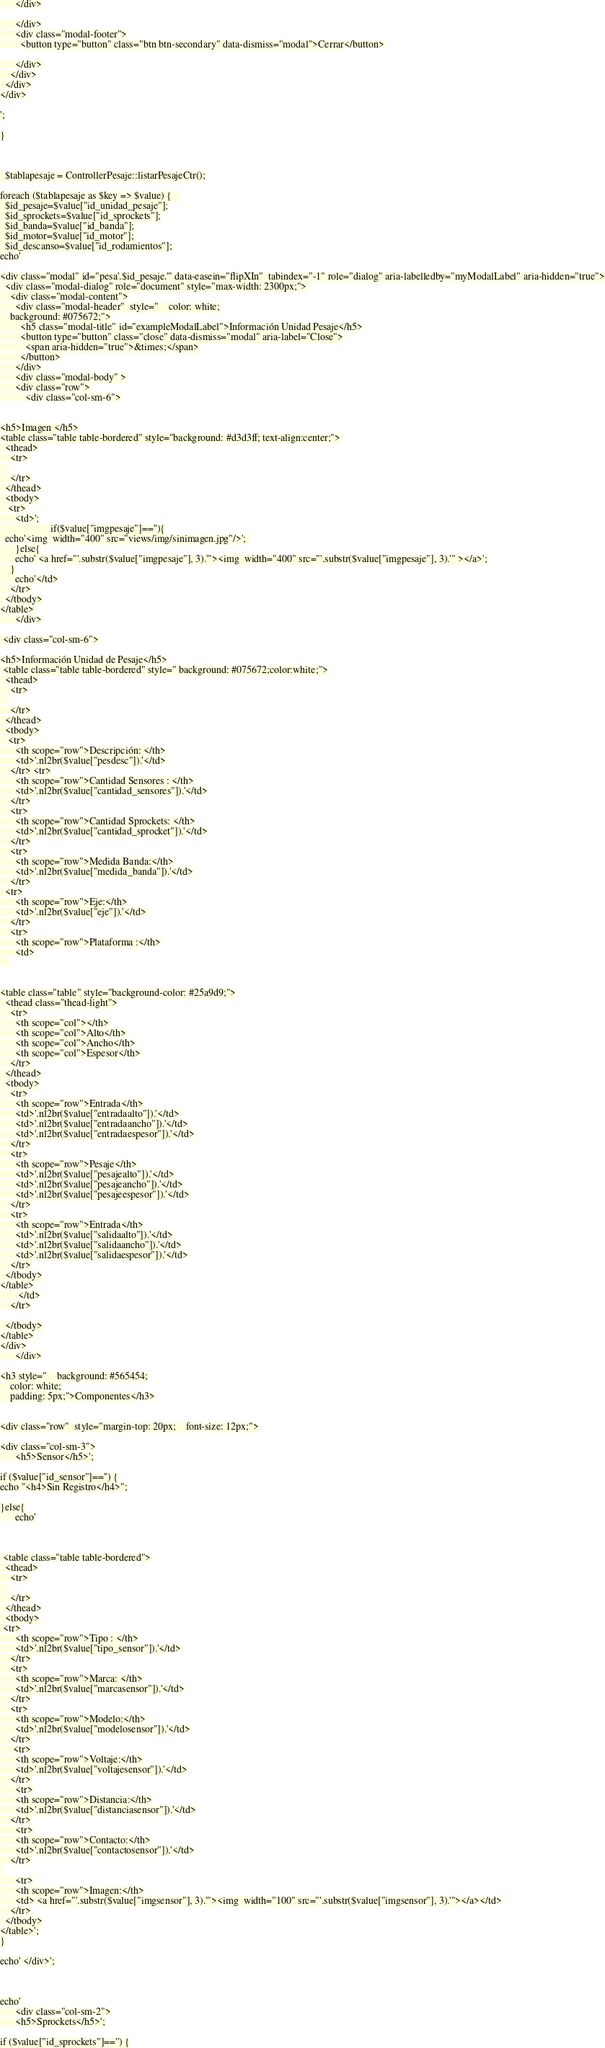Convert code to text. <code><loc_0><loc_0><loc_500><loc_500><_PHP_>
      </div>

      </div>
      <div class="modal-footer">
        <button type="button" class="btn btn-secondary" data-dismiss="modal">Cerrar</button>

      </div>
    </div>
  </div>
</div>

';

}



  $tablapesaje = ControllerPesaje::listarPesajeCtr();

foreach ($tablapesaje as $key => $value) {   
  $id_pesaje=$value["id_unidad_pesaje"];
  $id_sprockets=$value["id_sprockets"];
  $id_banda=$value["id_banda"];
  $id_motor=$value["id_motor"];
  $id_descanso=$value["id_rodamientos"];
echo'

<div class="modal" id="pesa'.$id_pesaje.'" data-easein="flipXIn"  tabindex="-1" role="dialog" aria-labelledby="myModalLabel" aria-hidden="true">
  <div class="modal-dialog" role="document" style="max-width: 2300px;">
    <div class="modal-content">
      <div class="modal-header"  style="    color: white;
    background: #075672;">
        <h5 class="modal-title" id="exampleModalLabel">Información Unidad Pesaje</h5>
        <button type="button" class="close" data-dismiss="modal" aria-label="Close">
          <span aria-hidden="true">&times;</span>
        </button>
      </div>
      <div class="modal-body" >
      <div class="row">
          <div class="col-sm-6">


<h5>Imagen </h5>
<table class="table table-bordered" style="background: #d3d3ff; text-align:center;">
  <thead>
    <tr>
   
    </tr>
  </thead>
  <tbody>
   <tr>
      <td>';
                    if($value["imgpesaje"]==''){
  echo'<img  width="400" src="views/img/sinimagen.jpg"/>'; 
      }else{
      echo' <a href="'.substr($value["imgpesaje"], 3).'"><img  width="400" src="'.substr($value["imgpesaje"], 3).'" ></a>';
    }
      echo'</td>
    </tr>
  </tbody>
</table>
      </div>

 <div class="col-sm-6">

<h5>Información Unidad de Pesaje</h5>
 <table class="table table-bordered" style=" background: #075672;color:white;">
  <thead>
    <tr>
   
    </tr>
  </thead>
  <tbody>
   <tr>
      <th scope="row">Descripción: </th>
      <td>'.nl2br($value["pesdesc"]).'</td>
    </tr> <tr>
      <th scope="row">Cantidad Sensores : </th>
      <td>'.nl2br($value["cantidad_sensores"]).'</td>
    </tr>
    <tr>
      <th scope="row">Cantidad Sprockets: </th>
      <td>'.nl2br($value["cantidad_sprocket"]).'</td>
    </tr>
    <tr>
      <th scope="row">Medida Banda:</th>
      <td>'.nl2br($value["medida_banda"]).'</td>
    </tr>
  <tr>
      <th scope="row">Eje:</th>
      <td>'.nl2br($value["eje"]).'</td>
    </tr>
    <tr>
      <th scope="row">Plataforma :</th>
      <td>
    


<table class="table" style="background-color: #25a9d9;">
  <thead class="thead-light">
    <tr>
      <th scope="col"></th>
      <th scope="col">Alto</th>
      <th scope="col">Ancho</th>
      <th scope="col">Espesor</th>
    </tr>
  </thead>
  <tbody>
    <tr>
      <th scope="row">Entrada</th>
      <td>'.nl2br($value["entradaalto"]).'</td>
      <td>'.nl2br($value["entradaancho"]).'</td>
      <td>'.nl2br($value["entradaespesor"]).'</td>
    </tr>
    <tr>
      <th scope="row">Pesaje</th>
      <td>'.nl2br($value["pesajealto"]).'</td>
      <td>'.nl2br($value["pesajeancho"]).'</td>
      <td>'.nl2br($value["pesajeespesor"]).'</td>
    </tr>
    <tr>
      <th scope="row">Entrada</th>
      <td>'.nl2br($value["salidaalto"]).'</td>
      <td>'.nl2br($value["salidaancho"]).'</td>
      <td>'.nl2br($value["salidaespesor"]).'</td>
    </tr>
  </tbody>
</table>
       </td>
    </tr>

  </tbody>
</table>
</div>
      </div>

<h3 style="    background: #565454;
    color: white;
    padding: 5px;">Componentes</h3>


<div class="row"  style="margin-top: 20px;    font-size: 12px;">

<div class="col-sm-3">
      <h5>Sensor</h5>';

if ($value["id_sensor"]=='') {
echo "<h4>Sin Registro</h4>";

}else{
      echo'



 <table class="table table-bordered">
  <thead>
    <tr>
   
    </tr>
  </thead>
  <tbody>
 <tr>
      <th scope="row">Tipo : </th>
      <td>'.nl2br($value["tipo_sensor"]).'</td>
    </tr>
    <tr>
      <th scope="row">Marca: </th>
      <td>'.nl2br($value["marcasensor"]).'</td>
    </tr>
    <tr>
      <th scope="row">Modelo:</th>
      <td>'.nl2br($value["modelosensor"]).'</td>
    </tr>
     <tr>
      <th scope="row">Voltaje:</th>
      <td>'.nl2br($value["voltajesensor"]).'</td>
    </tr>
      <tr>
      <th scope="row">Distancia:</th>
      <td>'.nl2br($value["distanciasensor"]).'</td>
    </tr>
      <tr>
      <th scope="row">Contacto:</th>
      <td>'.nl2br($value["contactosensor"]).'</td>
    </tr>
 
      <tr>
      <th scope="row">Imagen:</th>
      <td> <a href="'.substr($value["imgsensor"], 3).'"><img  width="100" src="'.substr($value["imgsensor"], 3).'"></a></td>
    </tr>
  </tbody>
</table>';
}

echo' </div>';



echo'
      <div class="col-sm-2">
      <h5>Sprockets</h5>';

if ($value["id_sprockets"]=='') {</code> 